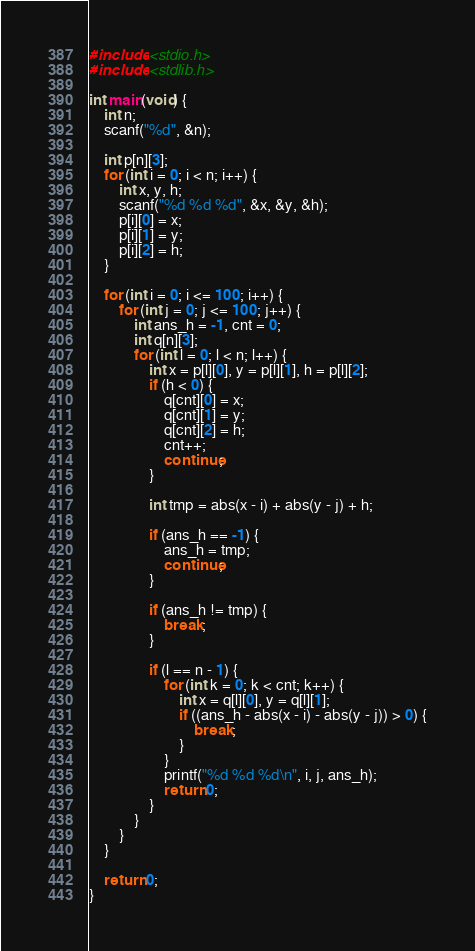Convert code to text. <code><loc_0><loc_0><loc_500><loc_500><_C_>#include <stdio.h>
#include <stdlib.h>

int main(void) {
    int n;
    scanf("%d", &n);

    int p[n][3];
    for (int i = 0; i < n; i++) {
        int x, y, h;
        scanf("%d %d %d", &x, &y, &h);
        p[i][0] = x;
        p[i][1] = y;
        p[i][2] = h;
    }

    for (int i = 0; i <= 100; i++) {
        for (int j = 0; j <= 100; j++) {
            int ans_h = -1, cnt = 0;
            int q[n][3];
            for (int l = 0; l < n; l++) {
                int x = p[l][0], y = p[l][1], h = p[l][2];
                if (h < 0) {
                    q[cnt][0] = x;
                    q[cnt][1] = y;
                    q[cnt][2] = h;
                    cnt++;
                    continue;
                }

                int tmp = abs(x - i) + abs(y - j) + h;

                if (ans_h == -1) {
                    ans_h = tmp;
                    continue;
                }

                if (ans_h != tmp) {
                    break;
                }

                if (l == n - 1) {
                    for (int k = 0; k < cnt; k++) {
                        int x = q[l][0], y = q[l][1];
                        if ((ans_h - abs(x - i) - abs(y - j)) > 0) {
                            break;
                        }
                    }
                    printf("%d %d %d\n", i, j, ans_h);
                    return 0;
                }
            }
        }
    }

    return 0;
}
</code> 